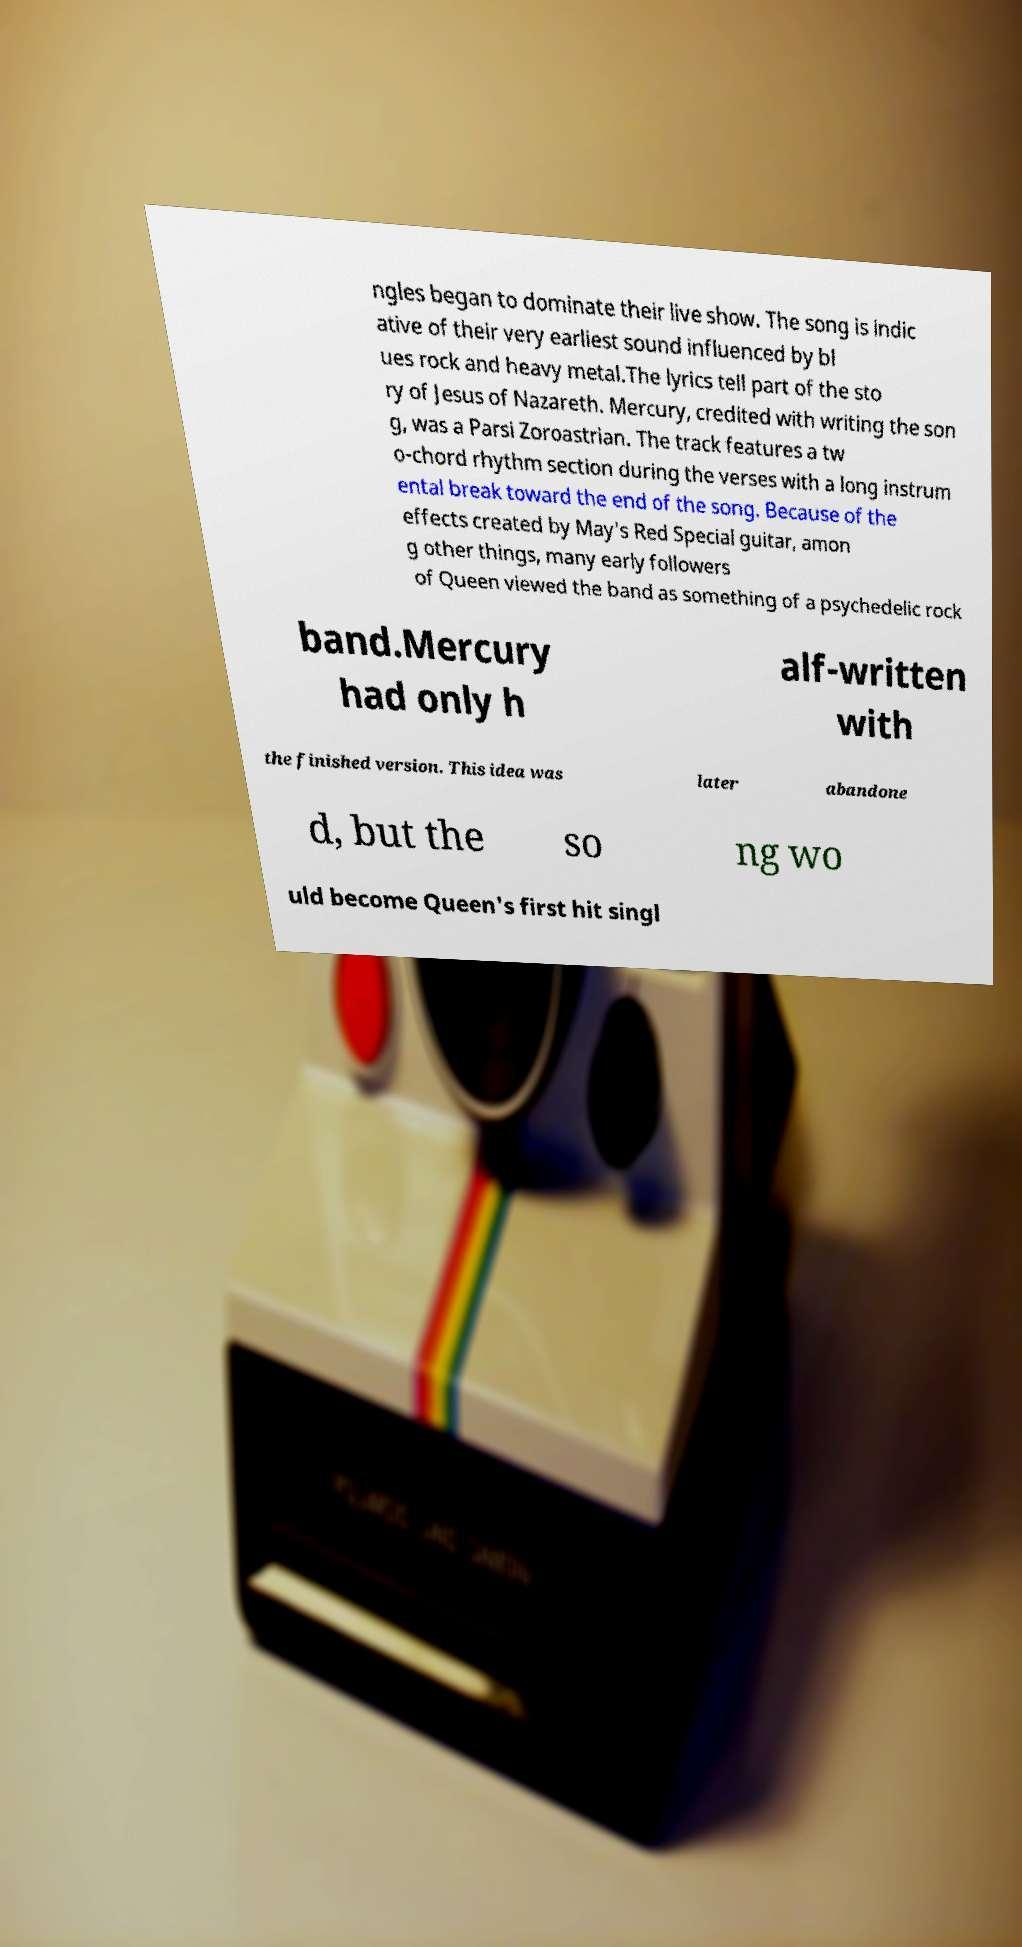I need the written content from this picture converted into text. Can you do that? ngles began to dominate their live show. The song is indic ative of their very earliest sound influenced by bl ues rock and heavy metal.The lyrics tell part of the sto ry of Jesus of Nazareth. Mercury, credited with writing the son g, was a Parsi Zoroastrian. The track features a tw o-chord rhythm section during the verses with a long instrum ental break toward the end of the song. Because of the effects created by May's Red Special guitar, amon g other things, many early followers of Queen viewed the band as something of a psychedelic rock band.Mercury had only h alf-written with the finished version. This idea was later abandone d, but the so ng wo uld become Queen's first hit singl 